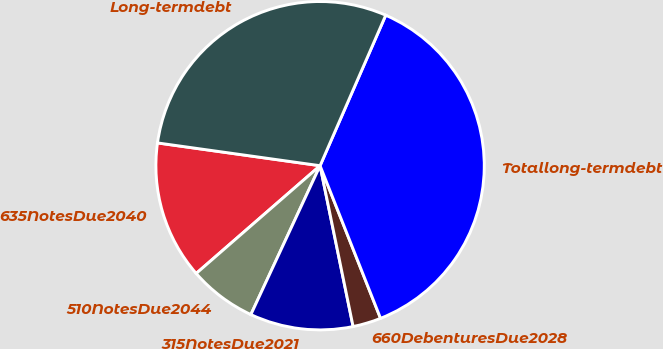<chart> <loc_0><loc_0><loc_500><loc_500><pie_chart><fcel>635NotesDue2040<fcel>510NotesDue2044<fcel>315NotesDue2021<fcel>660DebenturesDue2028<fcel>Totallong-termdebt<fcel>Long-termdebt<nl><fcel>13.61%<fcel>6.68%<fcel>10.15%<fcel>2.78%<fcel>37.45%<fcel>29.33%<nl></chart> 